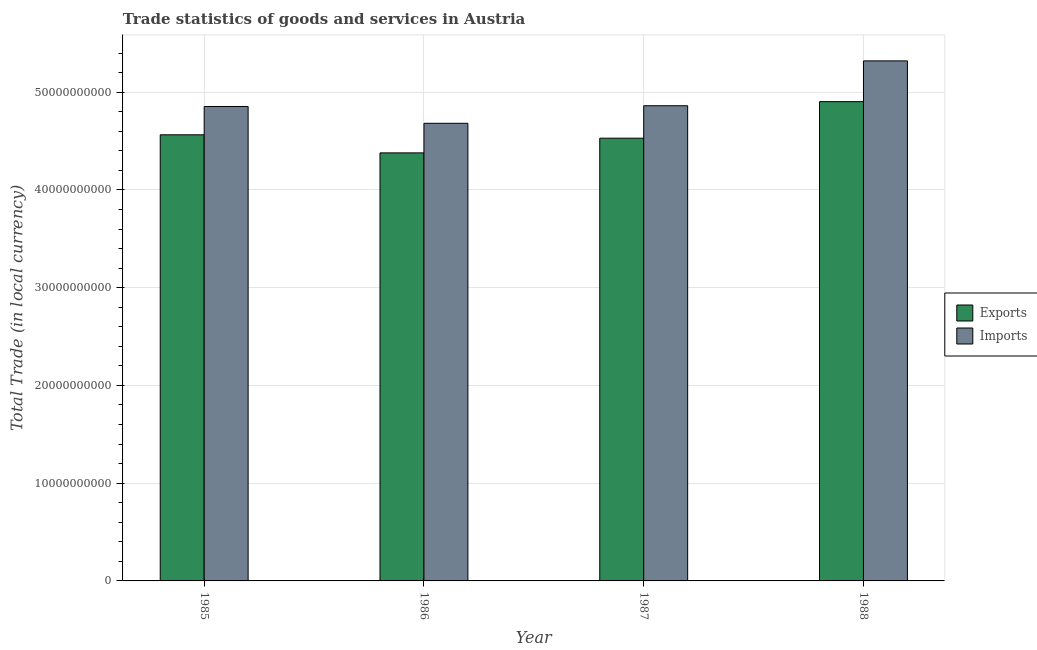How many bars are there on the 4th tick from the left?
Keep it short and to the point. 2. What is the label of the 1st group of bars from the left?
Offer a terse response. 1985. In how many cases, is the number of bars for a given year not equal to the number of legend labels?
Your answer should be compact. 0. What is the export of goods and services in 1988?
Make the answer very short. 4.90e+1. Across all years, what is the maximum export of goods and services?
Ensure brevity in your answer.  4.90e+1. Across all years, what is the minimum imports of goods and services?
Offer a very short reply. 4.68e+1. In which year was the export of goods and services maximum?
Provide a succinct answer. 1988. In which year was the export of goods and services minimum?
Offer a terse response. 1986. What is the total export of goods and services in the graph?
Offer a very short reply. 1.84e+11. What is the difference between the export of goods and services in 1985 and that in 1987?
Ensure brevity in your answer.  3.47e+08. What is the difference between the imports of goods and services in 1985 and the export of goods and services in 1987?
Offer a terse response. -7.57e+07. What is the average export of goods and services per year?
Make the answer very short. 4.59e+1. In the year 1987, what is the difference between the export of goods and services and imports of goods and services?
Provide a succinct answer. 0. In how many years, is the imports of goods and services greater than 18000000000 LCU?
Offer a very short reply. 4. What is the ratio of the export of goods and services in 1985 to that in 1986?
Your response must be concise. 1.04. Is the difference between the imports of goods and services in 1985 and 1986 greater than the difference between the export of goods and services in 1985 and 1986?
Provide a succinct answer. No. What is the difference between the highest and the second highest export of goods and services?
Give a very brief answer. 3.39e+09. What is the difference between the highest and the lowest imports of goods and services?
Give a very brief answer. 6.38e+09. In how many years, is the imports of goods and services greater than the average imports of goods and services taken over all years?
Ensure brevity in your answer.  1. Is the sum of the export of goods and services in 1985 and 1987 greater than the maximum imports of goods and services across all years?
Provide a succinct answer. Yes. What does the 2nd bar from the left in 1986 represents?
Offer a terse response. Imports. What does the 1st bar from the right in 1986 represents?
Make the answer very short. Imports. Are all the bars in the graph horizontal?
Your answer should be very brief. No. How many years are there in the graph?
Make the answer very short. 4. What is the difference between two consecutive major ticks on the Y-axis?
Ensure brevity in your answer.  1.00e+1. Does the graph contain grids?
Your answer should be very brief. Yes. How are the legend labels stacked?
Your response must be concise. Vertical. What is the title of the graph?
Offer a very short reply. Trade statistics of goods and services in Austria. What is the label or title of the Y-axis?
Your response must be concise. Total Trade (in local currency). What is the Total Trade (in local currency) in Exports in 1985?
Offer a very short reply. 4.56e+1. What is the Total Trade (in local currency) of Imports in 1985?
Ensure brevity in your answer.  4.85e+1. What is the Total Trade (in local currency) of Exports in 1986?
Offer a very short reply. 4.38e+1. What is the Total Trade (in local currency) in Imports in 1986?
Make the answer very short. 4.68e+1. What is the Total Trade (in local currency) in Exports in 1987?
Give a very brief answer. 4.53e+1. What is the Total Trade (in local currency) in Imports in 1987?
Give a very brief answer. 4.86e+1. What is the Total Trade (in local currency) of Exports in 1988?
Offer a very short reply. 4.90e+1. What is the Total Trade (in local currency) in Imports in 1988?
Keep it short and to the point. 5.32e+1. Across all years, what is the maximum Total Trade (in local currency) of Exports?
Provide a short and direct response. 4.90e+1. Across all years, what is the maximum Total Trade (in local currency) in Imports?
Your response must be concise. 5.32e+1. Across all years, what is the minimum Total Trade (in local currency) in Exports?
Your response must be concise. 4.38e+1. Across all years, what is the minimum Total Trade (in local currency) in Imports?
Make the answer very short. 4.68e+1. What is the total Total Trade (in local currency) in Exports in the graph?
Your answer should be very brief. 1.84e+11. What is the total Total Trade (in local currency) in Imports in the graph?
Your answer should be very brief. 1.97e+11. What is the difference between the Total Trade (in local currency) of Exports in 1985 and that in 1986?
Offer a very short reply. 1.85e+09. What is the difference between the Total Trade (in local currency) in Imports in 1985 and that in 1986?
Your response must be concise. 1.72e+09. What is the difference between the Total Trade (in local currency) of Exports in 1985 and that in 1987?
Provide a short and direct response. 3.47e+08. What is the difference between the Total Trade (in local currency) of Imports in 1985 and that in 1987?
Offer a very short reply. -7.57e+07. What is the difference between the Total Trade (in local currency) of Exports in 1985 and that in 1988?
Ensure brevity in your answer.  -3.39e+09. What is the difference between the Total Trade (in local currency) of Imports in 1985 and that in 1988?
Offer a very short reply. -4.67e+09. What is the difference between the Total Trade (in local currency) of Exports in 1986 and that in 1987?
Offer a terse response. -1.50e+09. What is the difference between the Total Trade (in local currency) in Imports in 1986 and that in 1987?
Your answer should be very brief. -1.79e+09. What is the difference between the Total Trade (in local currency) in Exports in 1986 and that in 1988?
Offer a very short reply. -5.24e+09. What is the difference between the Total Trade (in local currency) in Imports in 1986 and that in 1988?
Your answer should be compact. -6.38e+09. What is the difference between the Total Trade (in local currency) of Exports in 1987 and that in 1988?
Keep it short and to the point. -3.74e+09. What is the difference between the Total Trade (in local currency) in Imports in 1987 and that in 1988?
Give a very brief answer. -4.59e+09. What is the difference between the Total Trade (in local currency) of Exports in 1985 and the Total Trade (in local currency) of Imports in 1986?
Your response must be concise. -1.18e+09. What is the difference between the Total Trade (in local currency) of Exports in 1985 and the Total Trade (in local currency) of Imports in 1987?
Provide a succinct answer. -2.97e+09. What is the difference between the Total Trade (in local currency) in Exports in 1985 and the Total Trade (in local currency) in Imports in 1988?
Make the answer very short. -7.56e+09. What is the difference between the Total Trade (in local currency) in Exports in 1986 and the Total Trade (in local currency) in Imports in 1987?
Your response must be concise. -4.82e+09. What is the difference between the Total Trade (in local currency) of Exports in 1986 and the Total Trade (in local currency) of Imports in 1988?
Your response must be concise. -9.41e+09. What is the difference between the Total Trade (in local currency) of Exports in 1987 and the Total Trade (in local currency) of Imports in 1988?
Give a very brief answer. -7.91e+09. What is the average Total Trade (in local currency) in Exports per year?
Give a very brief answer. 4.59e+1. What is the average Total Trade (in local currency) of Imports per year?
Provide a short and direct response. 4.93e+1. In the year 1985, what is the difference between the Total Trade (in local currency) of Exports and Total Trade (in local currency) of Imports?
Your response must be concise. -2.90e+09. In the year 1986, what is the difference between the Total Trade (in local currency) of Exports and Total Trade (in local currency) of Imports?
Give a very brief answer. -3.03e+09. In the year 1987, what is the difference between the Total Trade (in local currency) of Exports and Total Trade (in local currency) of Imports?
Offer a very short reply. -3.32e+09. In the year 1988, what is the difference between the Total Trade (in local currency) of Exports and Total Trade (in local currency) of Imports?
Your answer should be very brief. -4.17e+09. What is the ratio of the Total Trade (in local currency) of Exports in 1985 to that in 1986?
Provide a short and direct response. 1.04. What is the ratio of the Total Trade (in local currency) in Imports in 1985 to that in 1986?
Provide a short and direct response. 1.04. What is the ratio of the Total Trade (in local currency) of Exports in 1985 to that in 1987?
Offer a very short reply. 1.01. What is the ratio of the Total Trade (in local currency) of Imports in 1985 to that in 1987?
Your answer should be very brief. 1. What is the ratio of the Total Trade (in local currency) in Exports in 1985 to that in 1988?
Provide a succinct answer. 0.93. What is the ratio of the Total Trade (in local currency) of Imports in 1985 to that in 1988?
Keep it short and to the point. 0.91. What is the ratio of the Total Trade (in local currency) of Exports in 1986 to that in 1987?
Your answer should be very brief. 0.97. What is the ratio of the Total Trade (in local currency) in Imports in 1986 to that in 1987?
Your answer should be very brief. 0.96. What is the ratio of the Total Trade (in local currency) of Exports in 1986 to that in 1988?
Provide a succinct answer. 0.89. What is the ratio of the Total Trade (in local currency) in Exports in 1987 to that in 1988?
Keep it short and to the point. 0.92. What is the ratio of the Total Trade (in local currency) of Imports in 1987 to that in 1988?
Provide a short and direct response. 0.91. What is the difference between the highest and the second highest Total Trade (in local currency) of Exports?
Your answer should be compact. 3.39e+09. What is the difference between the highest and the second highest Total Trade (in local currency) of Imports?
Keep it short and to the point. 4.59e+09. What is the difference between the highest and the lowest Total Trade (in local currency) of Exports?
Offer a very short reply. 5.24e+09. What is the difference between the highest and the lowest Total Trade (in local currency) of Imports?
Your answer should be very brief. 6.38e+09. 